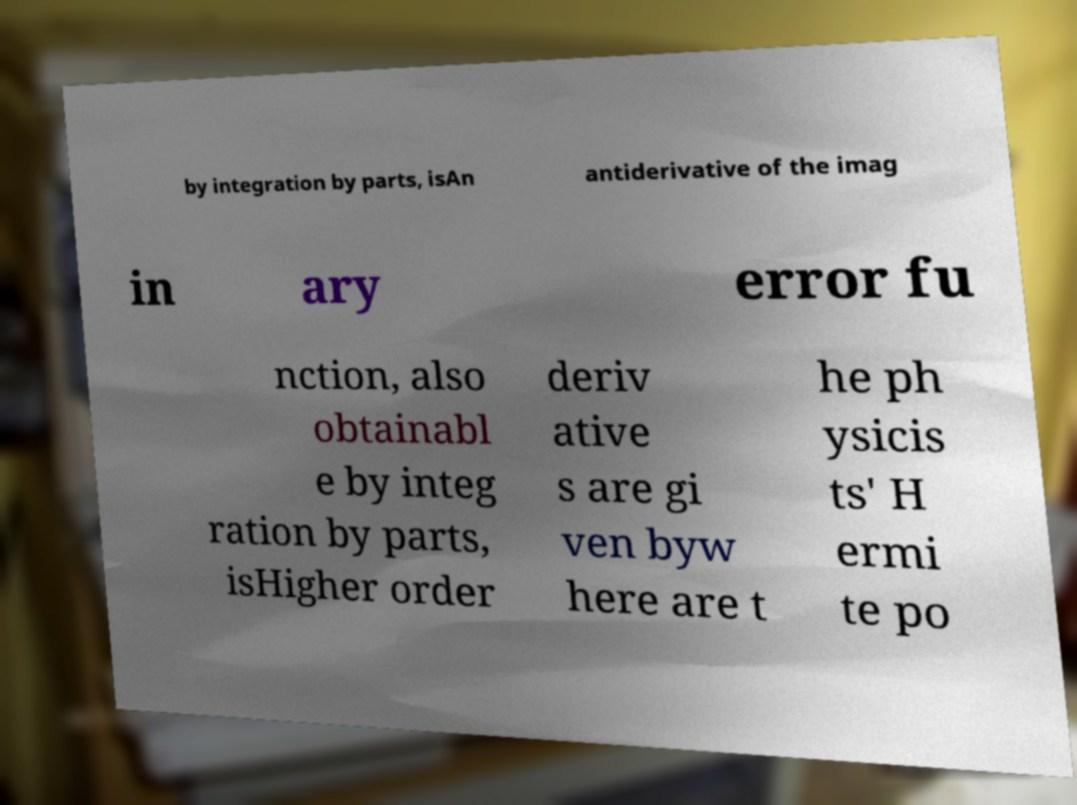There's text embedded in this image that I need extracted. Can you transcribe it verbatim? by integration by parts, isAn antiderivative of the imag in ary error fu nction, also obtainabl e by integ ration by parts, isHigher order deriv ative s are gi ven byw here are t he ph ysicis ts' H ermi te po 